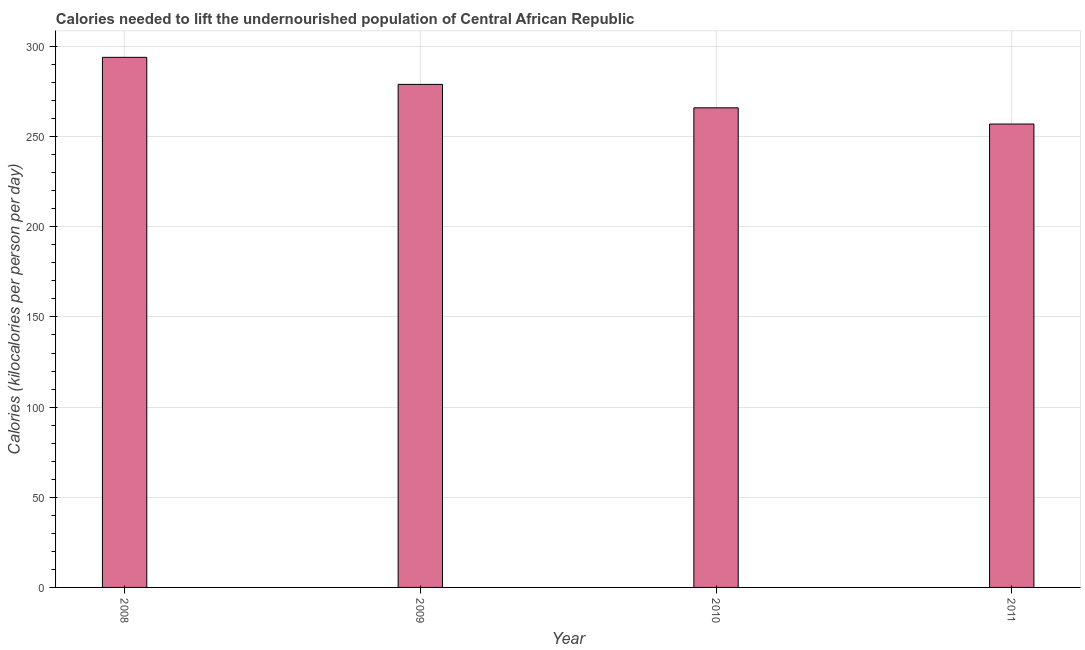What is the title of the graph?
Provide a succinct answer. Calories needed to lift the undernourished population of Central African Republic. What is the label or title of the Y-axis?
Provide a succinct answer. Calories (kilocalories per person per day). What is the depth of food deficit in 2009?
Give a very brief answer. 279. Across all years, what is the maximum depth of food deficit?
Ensure brevity in your answer.  294. Across all years, what is the minimum depth of food deficit?
Give a very brief answer. 257. What is the sum of the depth of food deficit?
Ensure brevity in your answer.  1096. What is the average depth of food deficit per year?
Your response must be concise. 274. What is the median depth of food deficit?
Offer a very short reply. 272.5. Do a majority of the years between 2009 and 2010 (inclusive) have depth of food deficit greater than 70 kilocalories?
Your answer should be compact. Yes. What is the ratio of the depth of food deficit in 2009 to that in 2011?
Your answer should be very brief. 1.09. Is the depth of food deficit in 2009 less than that in 2010?
Provide a succinct answer. No. What is the difference between the highest and the second highest depth of food deficit?
Provide a short and direct response. 15. What is the difference between the highest and the lowest depth of food deficit?
Your response must be concise. 37. Are all the bars in the graph horizontal?
Offer a very short reply. No. What is the difference between two consecutive major ticks on the Y-axis?
Your answer should be compact. 50. What is the Calories (kilocalories per person per day) of 2008?
Provide a succinct answer. 294. What is the Calories (kilocalories per person per day) in 2009?
Offer a very short reply. 279. What is the Calories (kilocalories per person per day) in 2010?
Make the answer very short. 266. What is the Calories (kilocalories per person per day) of 2011?
Give a very brief answer. 257. What is the difference between the Calories (kilocalories per person per day) in 2008 and 2009?
Provide a short and direct response. 15. What is the difference between the Calories (kilocalories per person per day) in 2008 and 2010?
Provide a succinct answer. 28. What is the difference between the Calories (kilocalories per person per day) in 2010 and 2011?
Ensure brevity in your answer.  9. What is the ratio of the Calories (kilocalories per person per day) in 2008 to that in 2009?
Make the answer very short. 1.05. What is the ratio of the Calories (kilocalories per person per day) in 2008 to that in 2010?
Your answer should be very brief. 1.1. What is the ratio of the Calories (kilocalories per person per day) in 2008 to that in 2011?
Offer a terse response. 1.14. What is the ratio of the Calories (kilocalories per person per day) in 2009 to that in 2010?
Offer a terse response. 1.05. What is the ratio of the Calories (kilocalories per person per day) in 2009 to that in 2011?
Your response must be concise. 1.09. What is the ratio of the Calories (kilocalories per person per day) in 2010 to that in 2011?
Keep it short and to the point. 1.03. 